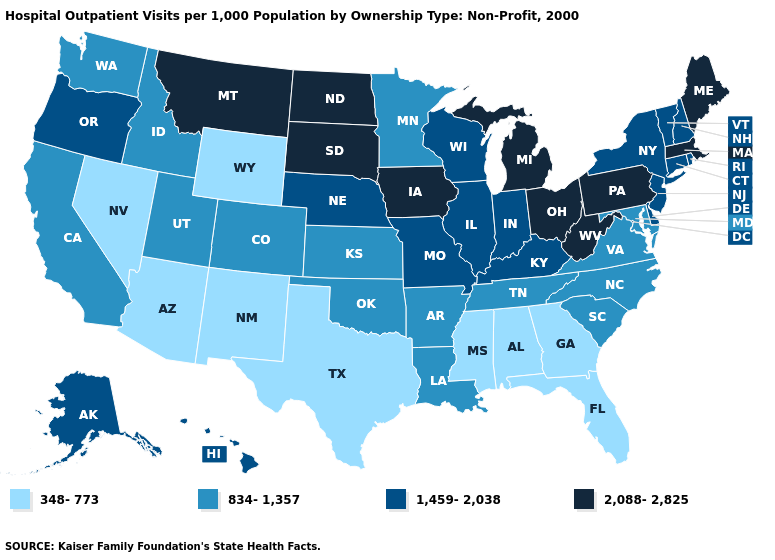Name the states that have a value in the range 348-773?
Keep it brief. Alabama, Arizona, Florida, Georgia, Mississippi, Nevada, New Mexico, Texas, Wyoming. Does Missouri have a lower value than Connecticut?
Concise answer only. No. Name the states that have a value in the range 348-773?
Concise answer only. Alabama, Arizona, Florida, Georgia, Mississippi, Nevada, New Mexico, Texas, Wyoming. Name the states that have a value in the range 1,459-2,038?
Answer briefly. Alaska, Connecticut, Delaware, Hawaii, Illinois, Indiana, Kentucky, Missouri, Nebraska, New Hampshire, New Jersey, New York, Oregon, Rhode Island, Vermont, Wisconsin. What is the value of Illinois?
Answer briefly. 1,459-2,038. Does Maryland have a lower value than North Carolina?
Give a very brief answer. No. Among the states that border Oklahoma , does Texas have the lowest value?
Write a very short answer. Yes. Does the first symbol in the legend represent the smallest category?
Keep it brief. Yes. Among the states that border New Jersey , does New York have the highest value?
Quick response, please. No. What is the value of Connecticut?
Short answer required. 1,459-2,038. Does the first symbol in the legend represent the smallest category?
Keep it brief. Yes. What is the value of California?
Write a very short answer. 834-1,357. How many symbols are there in the legend?
Keep it brief. 4. Name the states that have a value in the range 1,459-2,038?
Quick response, please. Alaska, Connecticut, Delaware, Hawaii, Illinois, Indiana, Kentucky, Missouri, Nebraska, New Hampshire, New Jersey, New York, Oregon, Rhode Island, Vermont, Wisconsin. What is the value of Vermont?
Write a very short answer. 1,459-2,038. 